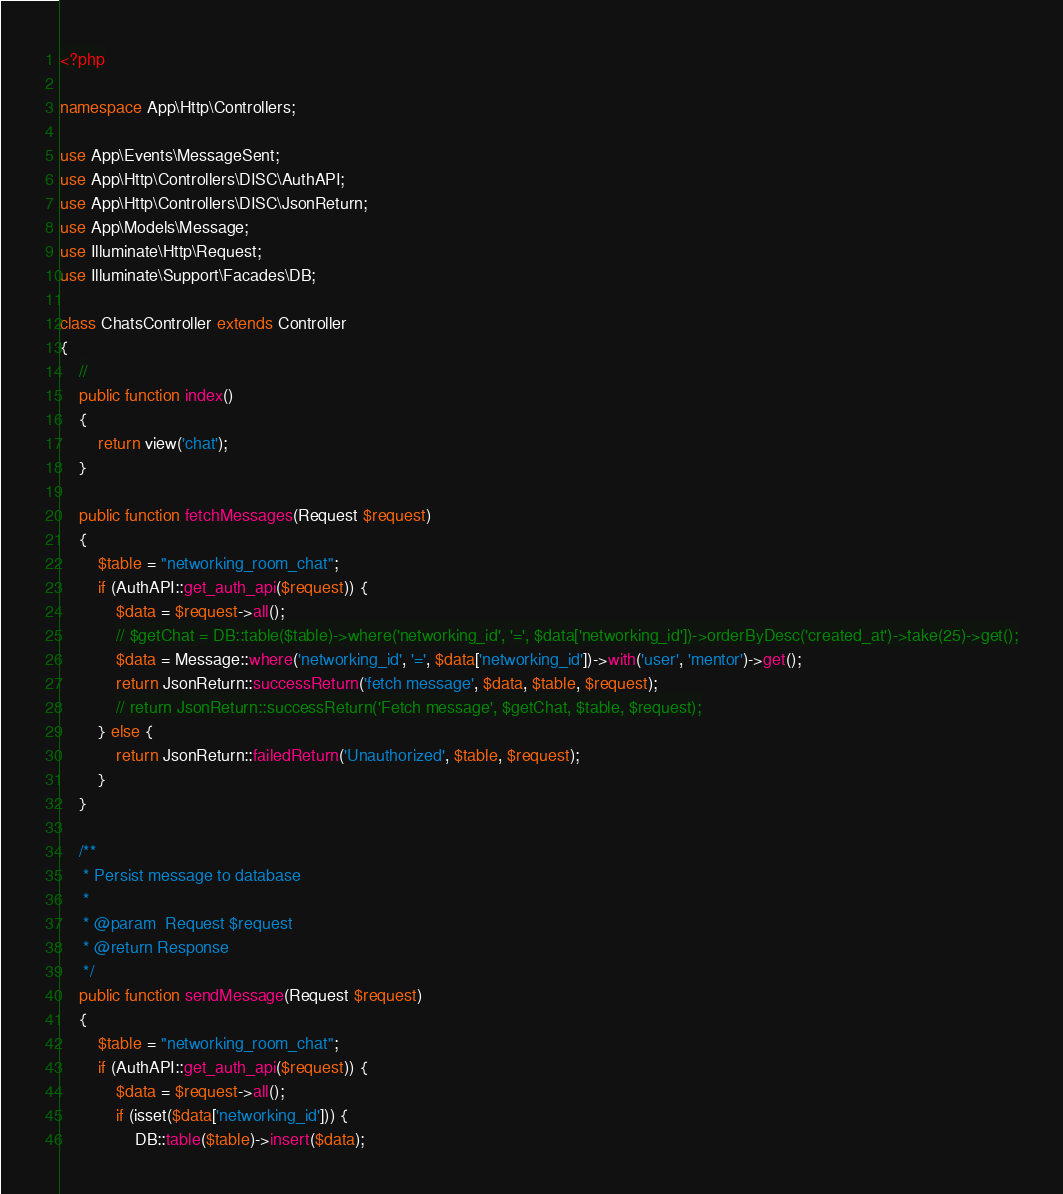Convert code to text. <code><loc_0><loc_0><loc_500><loc_500><_PHP_><?php

namespace App\Http\Controllers;

use App\Events\MessageSent;
use App\Http\Controllers\DISC\AuthAPI;
use App\Http\Controllers\DISC\JsonReturn;
use App\Models\Message;
use Illuminate\Http\Request;
use Illuminate\Support\Facades\DB;

class ChatsController extends Controller
{
    //
    public function index()
    {
        return view('chat');
    }

    public function fetchMessages(Request $request)
    {
        $table = "networking_room_chat";
        if (AuthAPI::get_auth_api($request)) {
            $data = $request->all();
            // $getChat = DB::table($table)->where('networking_id', '=', $data['networking_id'])->orderByDesc('created_at')->take(25)->get();
            $data = Message::where('networking_id', '=', $data['networking_id'])->with('user', 'mentor')->get();
            return JsonReturn::successReturn('fetch message', $data, $table, $request);
            // return JsonReturn::successReturn('Fetch message', $getChat, $table, $request);
        } else {
            return JsonReturn::failedReturn('Unauthorized', $table, $request);
        }
    }

    /**
     * Persist message to database
     *
     * @param  Request $request
     * @return Response
     */
    public function sendMessage(Request $request)
    {
        $table = "networking_room_chat";
        if (AuthAPI::get_auth_api($request)) {
            $data = $request->all();
            if (isset($data['networking_id'])) {
                DB::table($table)->insert($data);</code> 